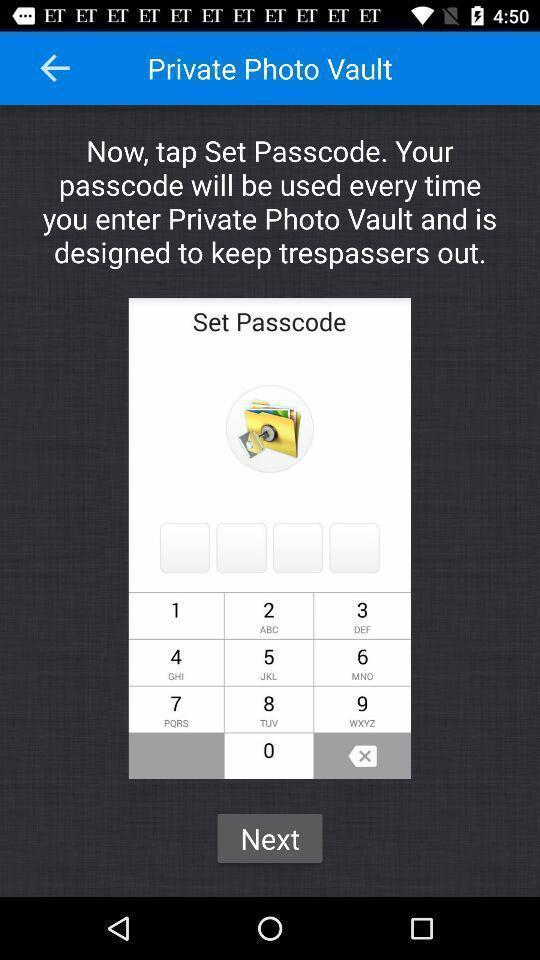What details can you identify in this image? Screen displaying information about a picture lock application. 